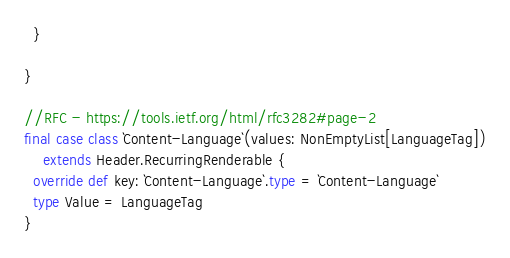<code> <loc_0><loc_0><loc_500><loc_500><_Scala_>  }

}

//RFC - https://tools.ietf.org/html/rfc3282#page-2
final case class `Content-Language`(values: NonEmptyList[LanguageTag])
    extends Header.RecurringRenderable {
  override def key: `Content-Language`.type = `Content-Language`
  type Value = LanguageTag
}
</code> 